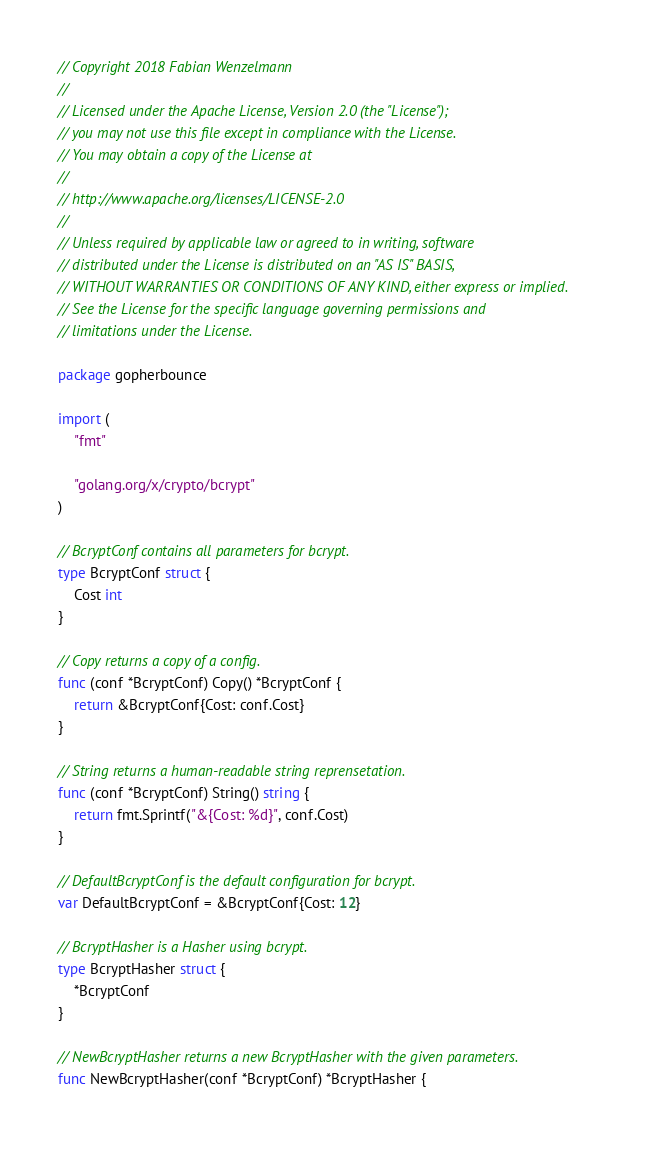Convert code to text. <code><loc_0><loc_0><loc_500><loc_500><_Go_>// Copyright 2018 Fabian Wenzelmann
//
// Licensed under the Apache License, Version 2.0 (the "License");
// you may not use this file except in compliance with the License.
// You may obtain a copy of the License at
//
// http://www.apache.org/licenses/LICENSE-2.0
//
// Unless required by applicable law or agreed to in writing, software
// distributed under the License is distributed on an "AS IS" BASIS,
// WITHOUT WARRANTIES OR CONDITIONS OF ANY KIND, either express or implied.
// See the License for the specific language governing permissions and
// limitations under the License.

package gopherbounce

import (
	"fmt"

	"golang.org/x/crypto/bcrypt"
)

// BcryptConf contains all parameters for bcrypt.
type BcryptConf struct {
	Cost int
}

// Copy returns a copy of a config.
func (conf *BcryptConf) Copy() *BcryptConf {
	return &BcryptConf{Cost: conf.Cost}
}

// String returns a human-readable string reprensetation.
func (conf *BcryptConf) String() string {
	return fmt.Sprintf("&{Cost: %d}", conf.Cost)
}

// DefaultBcryptConf is the default configuration for bcrypt.
var DefaultBcryptConf = &BcryptConf{Cost: 12}

// BcryptHasher is a Hasher using bcrypt.
type BcryptHasher struct {
	*BcryptConf
}

// NewBcryptHasher returns a new BcryptHasher with the given parameters.
func NewBcryptHasher(conf *BcryptConf) *BcryptHasher {</code> 